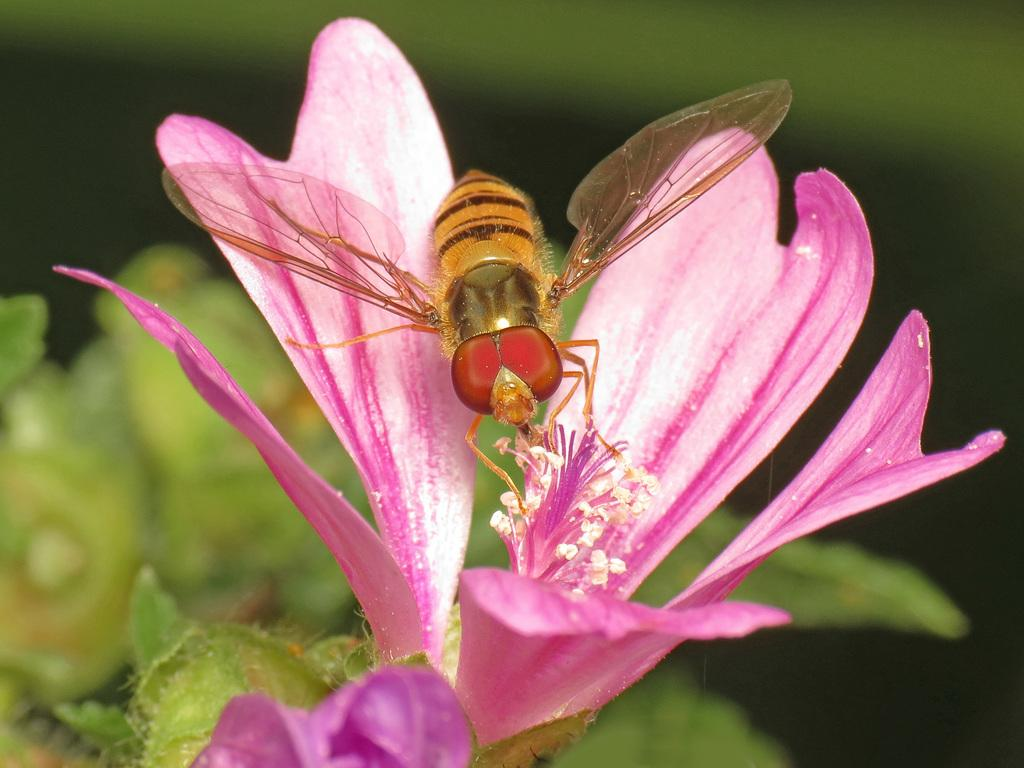What is the main subject of the image? There is an insect on a flower in the image. What can be seen in the background of the image? There are leaves visible in the background of the image. How would you describe the background of the image? The background appears blurry. Is the insect flying on a skate in the image? No, there is no skate present in the image, and the insect is not shown flying. 